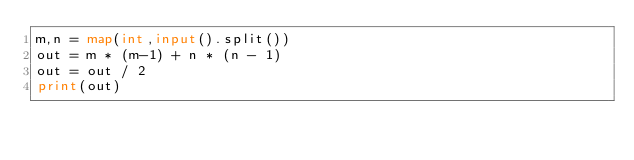Convert code to text. <code><loc_0><loc_0><loc_500><loc_500><_Python_>m,n = map(int,input().split())
out = m * (m-1) + n * (n - 1)
out = out / 2
print(out)</code> 